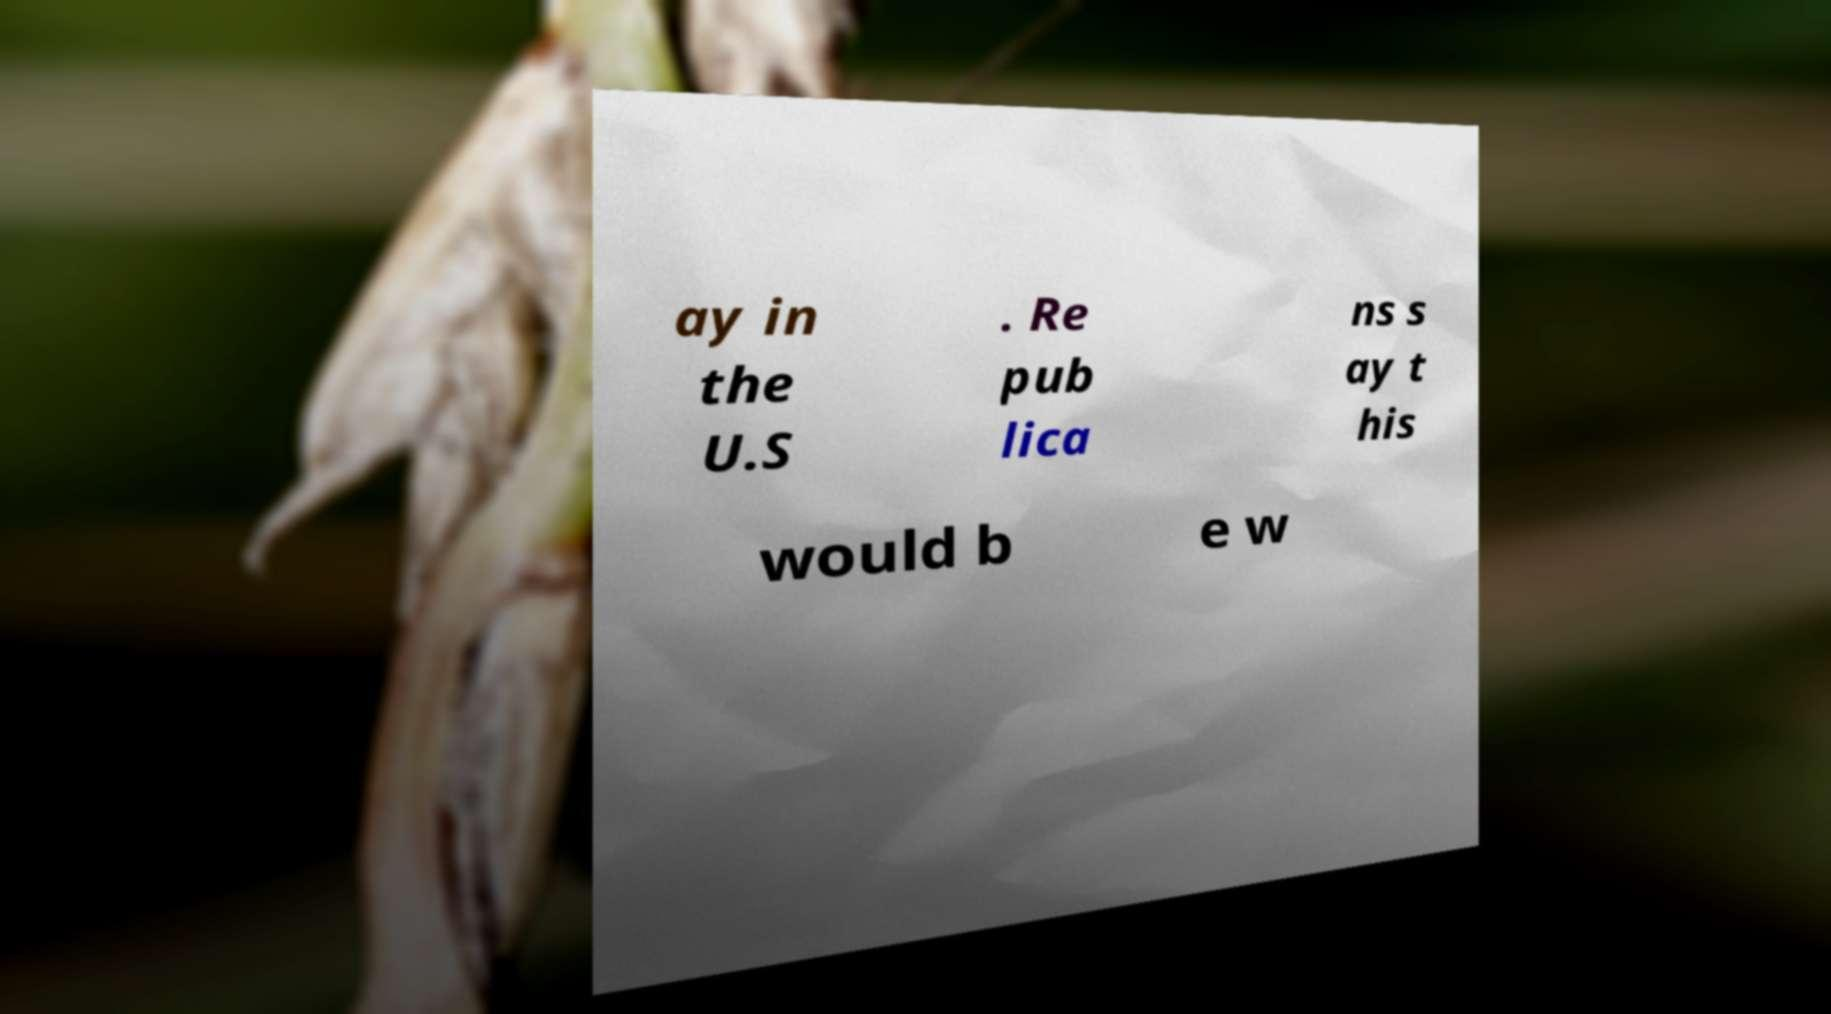I need the written content from this picture converted into text. Can you do that? ay in the U.S . Re pub lica ns s ay t his would b e w 